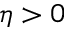<formula> <loc_0><loc_0><loc_500><loc_500>\eta > 0</formula> 